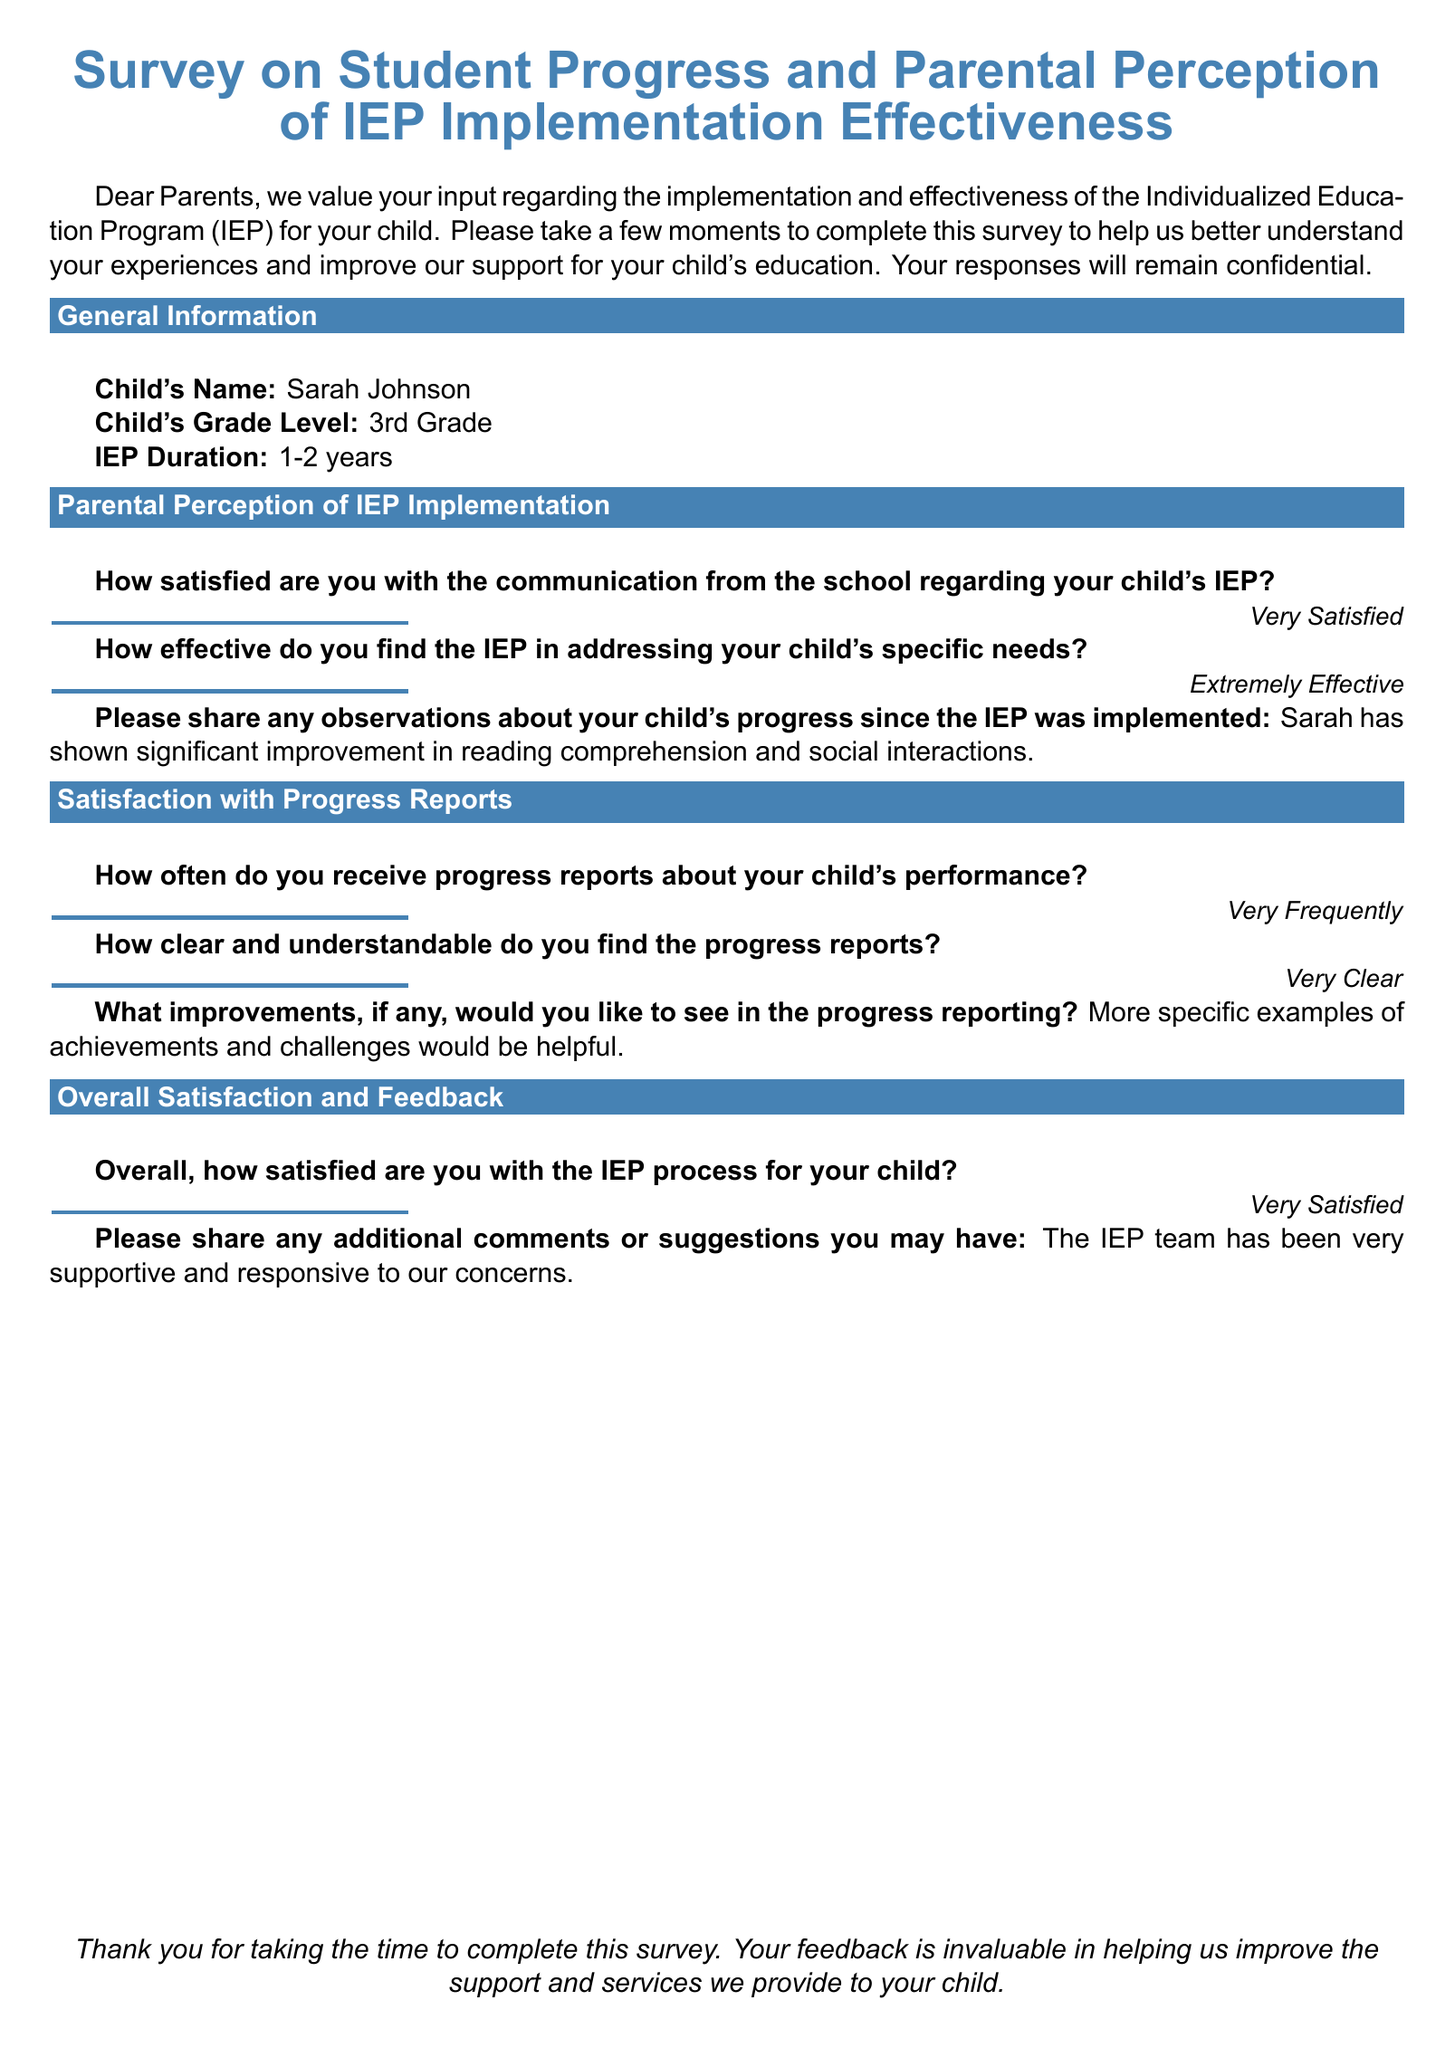What is the child's name? The child's name is explicitly mentioned in the document under the general information section.
Answer: Sarah Johnson What grade is the child in? The child's grade level is stated in the general information section of the document.
Answer: 3rd Grade How long has the IEP been in place? The duration of the IEP is specified in the document under general information.
Answer: 1-2 years How effective do parents find the IEP in addressing needs? The parent's satisfaction with the IEP's effectiveness is expressed in the parental perception section.
Answer: Extremely Effective What specific improvements has the child shown? The document includes an observation regarding the child's progress since the IEP implementation.
Answer: Significant improvement in reading comprehension and social interactions What improvements do parents want in progress reporting? The document asks for suggestions regarding the progress reports and includes responses related to this.
Answer: More specific examples of achievements and challenges would be helpful How often do parents receive progress reports? The frequency of progress report receipt is indicated in the satisfaction with progress reports section.
Answer: Very Frequently What is the overall satisfaction level with the IEP process? The overall satisfaction with the IEP process is summarized in the overall satisfaction and feedback section.
Answer: Very Satisfied Who has been supportive and responsive to concerns? The document includes a comment about the support from the IEP team, as noted by the parent.
Answer: The IEP team 